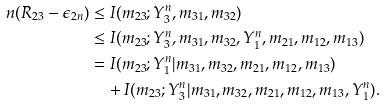Convert formula to latex. <formula><loc_0><loc_0><loc_500><loc_500>n ( R _ { 2 3 } - \epsilon _ { 2 n } ) & \leq I ( m _ { 2 3 } ; Y _ { 3 } ^ { n } , m _ { 3 1 } , m _ { 3 2 } ) \\ & \leq I ( m _ { 2 3 } ; Y _ { 3 } ^ { n } , m _ { 3 1 } , m _ { 3 2 } , Y _ { 1 } ^ { n } , m _ { 2 1 } , m _ { 1 2 } , m _ { 1 3 } ) \\ & = I ( m _ { 2 3 } ; Y _ { 1 } ^ { n } | m _ { 3 1 } , m _ { 3 2 } , m _ { 2 1 } , m _ { 1 2 } , m _ { 1 3 } ) \\ & \quad + I ( m _ { 2 3 } ; Y _ { 3 } ^ { n } | m _ { 3 1 } , m _ { 3 2 } , m _ { 2 1 } , m _ { 1 2 } , m _ { 1 3 } , Y _ { 1 } ^ { n } ) .</formula> 